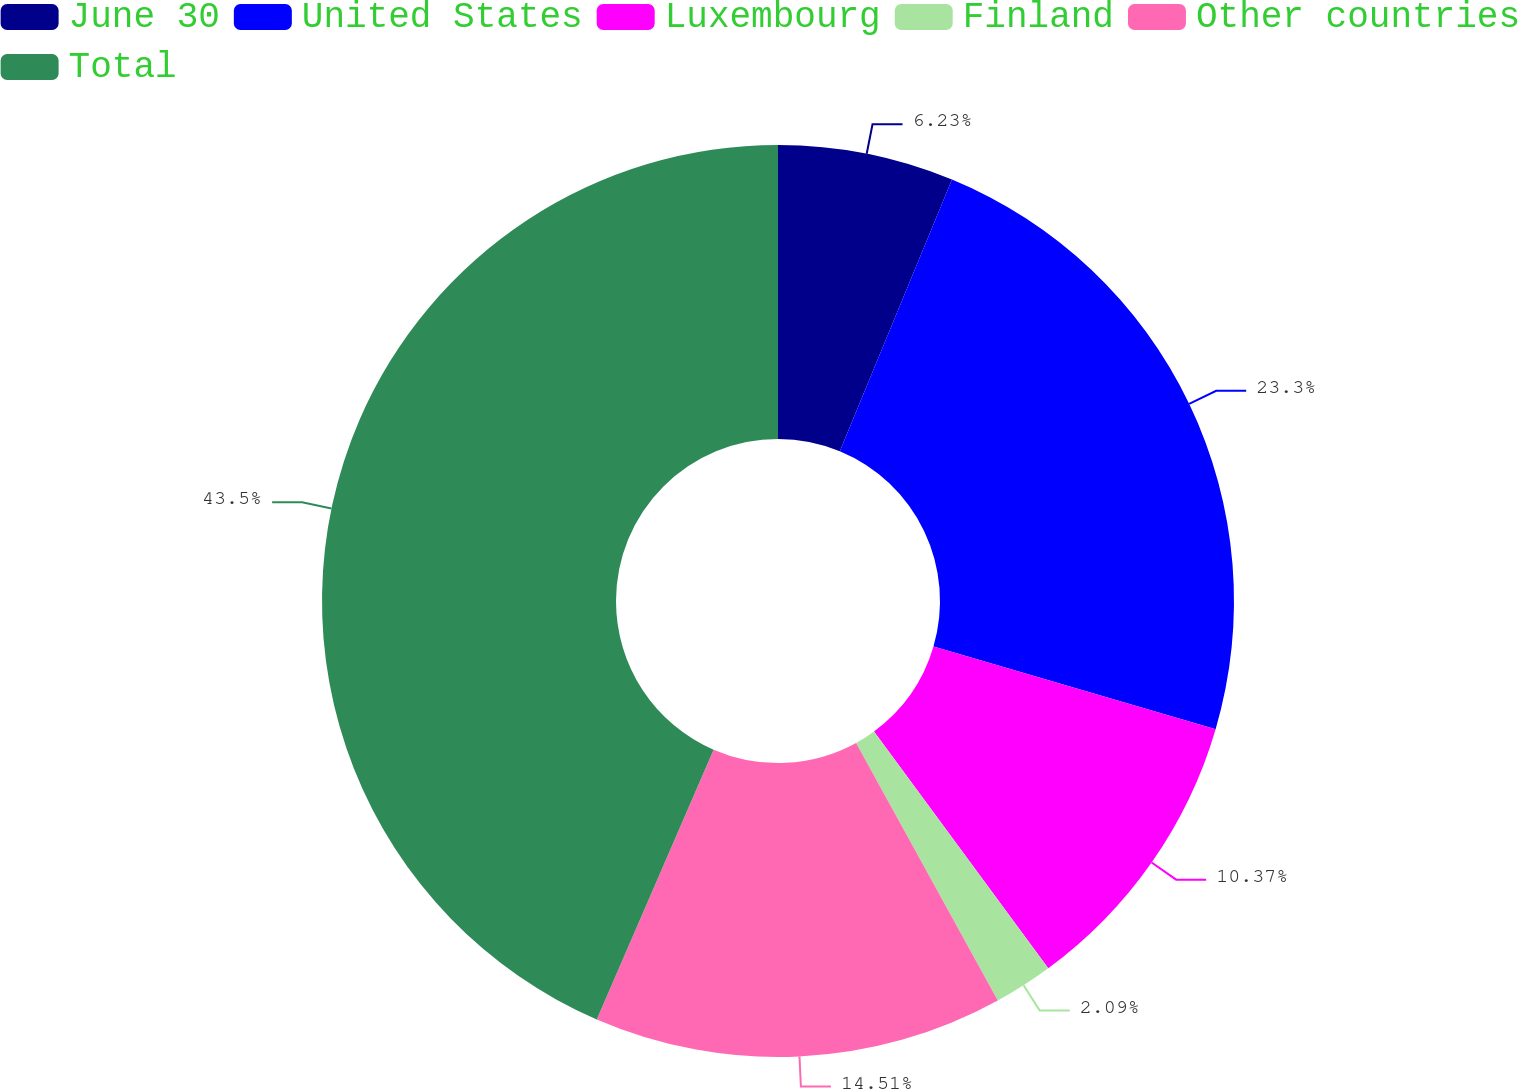Convert chart to OTSL. <chart><loc_0><loc_0><loc_500><loc_500><pie_chart><fcel>June 30<fcel>United States<fcel>Luxembourg<fcel>Finland<fcel>Other countries<fcel>Total<nl><fcel>6.23%<fcel>23.3%<fcel>10.37%<fcel>2.09%<fcel>14.51%<fcel>43.49%<nl></chart> 